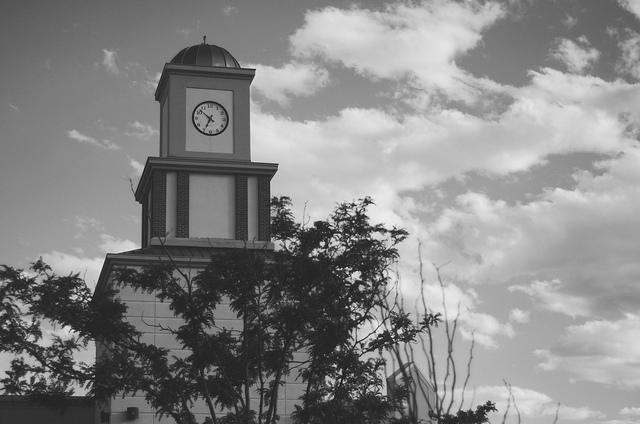Is there something on top of the dome of the tower?
Concise answer only. Yes. What is the weather in this photo?
Quick response, please. Partly cloudy. How many vertical lines are seen in the picture?
Concise answer only. 6. 